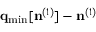<formula> <loc_0><loc_0><loc_500><loc_500>{ q } _ { \min } [ { n } ^ { ( 1 ) } ] - { n } ^ { ( 1 ) }</formula> 